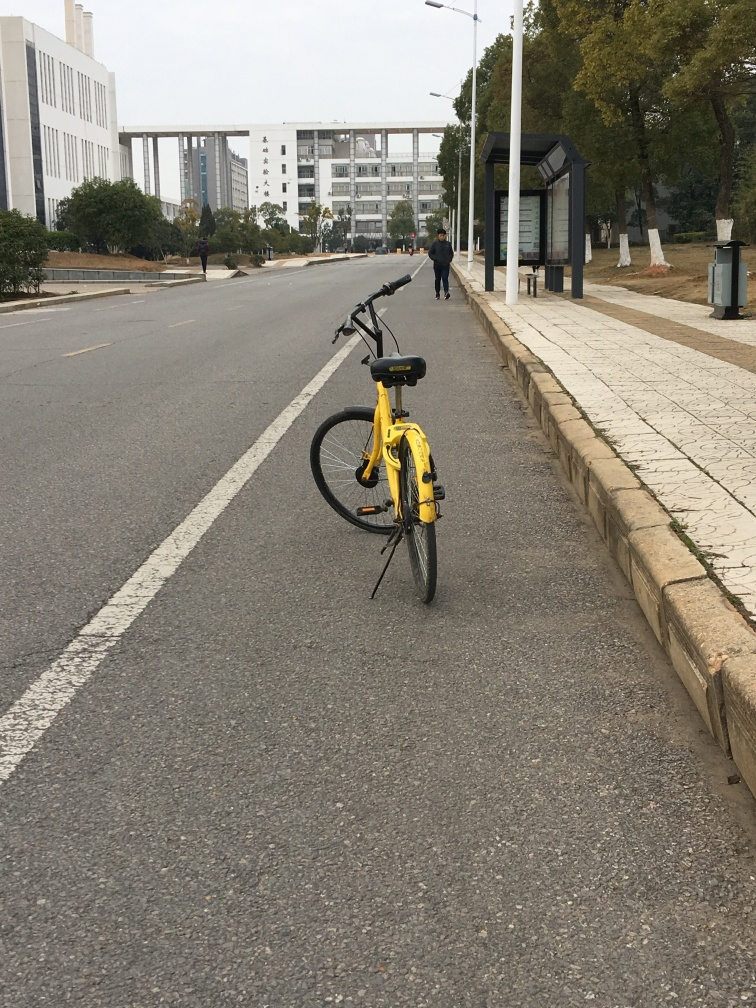Is the photo of good quality?
A. Yes
B. No
Answer with the option's letter from the given choices directly.
 A. 